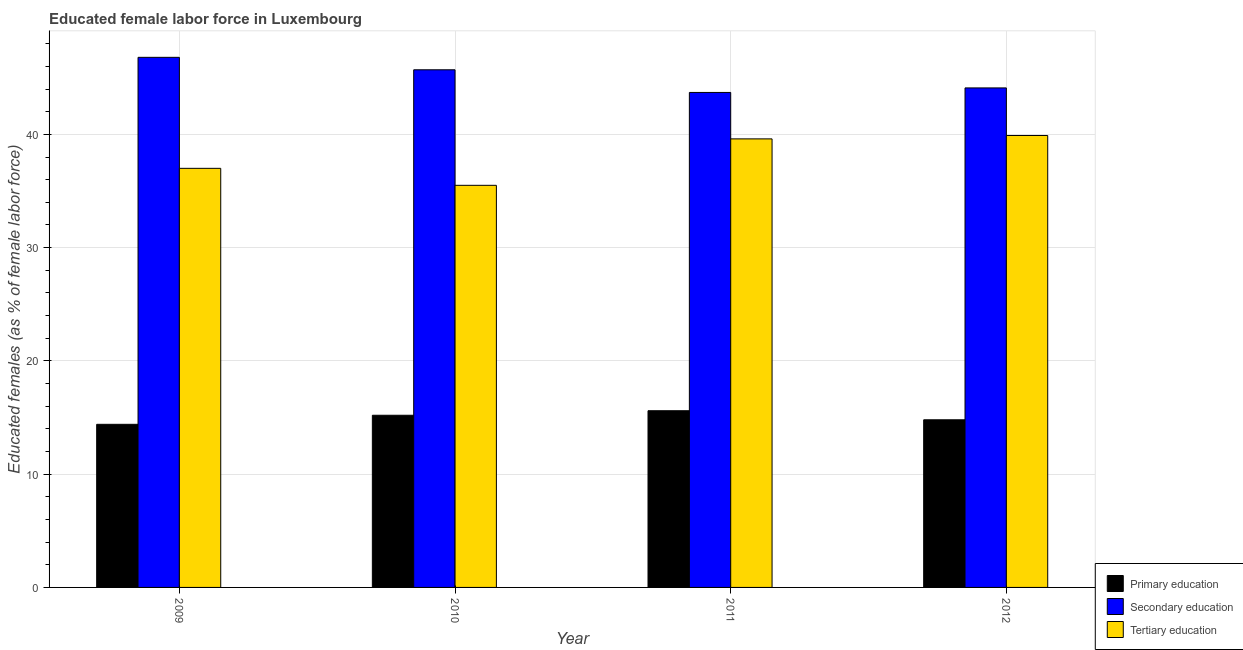How many different coloured bars are there?
Your answer should be compact. 3. Are the number of bars per tick equal to the number of legend labels?
Offer a terse response. Yes. Are the number of bars on each tick of the X-axis equal?
Make the answer very short. Yes. How many bars are there on the 4th tick from the right?
Make the answer very short. 3. What is the label of the 4th group of bars from the left?
Offer a very short reply. 2012. In how many cases, is the number of bars for a given year not equal to the number of legend labels?
Give a very brief answer. 0. What is the percentage of female labor force who received secondary education in 2010?
Your response must be concise. 45.7. Across all years, what is the maximum percentage of female labor force who received tertiary education?
Offer a very short reply. 39.9. Across all years, what is the minimum percentage of female labor force who received primary education?
Offer a terse response. 14.4. In which year was the percentage of female labor force who received primary education maximum?
Your answer should be compact. 2011. What is the total percentage of female labor force who received secondary education in the graph?
Make the answer very short. 180.3. What is the difference between the percentage of female labor force who received primary education in 2009 and that in 2010?
Offer a very short reply. -0.8. What is the difference between the percentage of female labor force who received primary education in 2011 and the percentage of female labor force who received secondary education in 2012?
Your answer should be compact. 0.8. What is the average percentage of female labor force who received tertiary education per year?
Provide a short and direct response. 38. In how many years, is the percentage of female labor force who received tertiary education greater than 34 %?
Your response must be concise. 4. What is the ratio of the percentage of female labor force who received primary education in 2009 to that in 2010?
Provide a succinct answer. 0.95. What is the difference between the highest and the second highest percentage of female labor force who received secondary education?
Make the answer very short. 1.1. What is the difference between the highest and the lowest percentage of female labor force who received primary education?
Provide a short and direct response. 1.2. Is the sum of the percentage of female labor force who received secondary education in 2009 and 2012 greater than the maximum percentage of female labor force who received primary education across all years?
Offer a terse response. Yes. What does the 2nd bar from the left in 2009 represents?
Keep it short and to the point. Secondary education. What does the 1st bar from the right in 2010 represents?
Your answer should be very brief. Tertiary education. What is the difference between two consecutive major ticks on the Y-axis?
Provide a succinct answer. 10. Does the graph contain any zero values?
Offer a terse response. No. How many legend labels are there?
Provide a short and direct response. 3. How are the legend labels stacked?
Provide a short and direct response. Vertical. What is the title of the graph?
Offer a terse response. Educated female labor force in Luxembourg. What is the label or title of the Y-axis?
Keep it short and to the point. Educated females (as % of female labor force). What is the Educated females (as % of female labor force) in Primary education in 2009?
Your answer should be compact. 14.4. What is the Educated females (as % of female labor force) in Secondary education in 2009?
Your answer should be very brief. 46.8. What is the Educated females (as % of female labor force) in Tertiary education in 2009?
Give a very brief answer. 37. What is the Educated females (as % of female labor force) in Primary education in 2010?
Your answer should be very brief. 15.2. What is the Educated females (as % of female labor force) in Secondary education in 2010?
Provide a short and direct response. 45.7. What is the Educated females (as % of female labor force) of Tertiary education in 2010?
Offer a terse response. 35.5. What is the Educated females (as % of female labor force) in Primary education in 2011?
Your response must be concise. 15.6. What is the Educated females (as % of female labor force) of Secondary education in 2011?
Offer a terse response. 43.7. What is the Educated females (as % of female labor force) in Tertiary education in 2011?
Your answer should be very brief. 39.6. What is the Educated females (as % of female labor force) in Primary education in 2012?
Provide a succinct answer. 14.8. What is the Educated females (as % of female labor force) of Secondary education in 2012?
Make the answer very short. 44.1. What is the Educated females (as % of female labor force) in Tertiary education in 2012?
Your response must be concise. 39.9. Across all years, what is the maximum Educated females (as % of female labor force) in Primary education?
Your answer should be very brief. 15.6. Across all years, what is the maximum Educated females (as % of female labor force) of Secondary education?
Give a very brief answer. 46.8. Across all years, what is the maximum Educated females (as % of female labor force) of Tertiary education?
Offer a terse response. 39.9. Across all years, what is the minimum Educated females (as % of female labor force) of Primary education?
Provide a succinct answer. 14.4. Across all years, what is the minimum Educated females (as % of female labor force) of Secondary education?
Provide a short and direct response. 43.7. Across all years, what is the minimum Educated females (as % of female labor force) in Tertiary education?
Your answer should be compact. 35.5. What is the total Educated females (as % of female labor force) of Primary education in the graph?
Offer a terse response. 60. What is the total Educated females (as % of female labor force) in Secondary education in the graph?
Your answer should be compact. 180.3. What is the total Educated females (as % of female labor force) in Tertiary education in the graph?
Your answer should be compact. 152. What is the difference between the Educated females (as % of female labor force) of Secondary education in 2009 and that in 2010?
Offer a terse response. 1.1. What is the difference between the Educated females (as % of female labor force) in Primary education in 2009 and that in 2011?
Ensure brevity in your answer.  -1.2. What is the difference between the Educated females (as % of female labor force) in Secondary education in 2009 and that in 2011?
Offer a terse response. 3.1. What is the difference between the Educated females (as % of female labor force) in Primary education in 2009 and that in 2012?
Your answer should be very brief. -0.4. What is the difference between the Educated females (as % of female labor force) in Secondary education in 2009 and that in 2012?
Your answer should be very brief. 2.7. What is the difference between the Educated females (as % of female labor force) of Primary education in 2010 and that in 2011?
Offer a terse response. -0.4. What is the difference between the Educated females (as % of female labor force) in Primary education in 2010 and that in 2012?
Keep it short and to the point. 0.4. What is the difference between the Educated females (as % of female labor force) in Tertiary education in 2011 and that in 2012?
Provide a short and direct response. -0.3. What is the difference between the Educated females (as % of female labor force) of Primary education in 2009 and the Educated females (as % of female labor force) of Secondary education in 2010?
Your answer should be compact. -31.3. What is the difference between the Educated females (as % of female labor force) in Primary education in 2009 and the Educated females (as % of female labor force) in Tertiary education in 2010?
Ensure brevity in your answer.  -21.1. What is the difference between the Educated females (as % of female labor force) of Primary education in 2009 and the Educated females (as % of female labor force) of Secondary education in 2011?
Your answer should be very brief. -29.3. What is the difference between the Educated females (as % of female labor force) of Primary education in 2009 and the Educated females (as % of female labor force) of Tertiary education in 2011?
Keep it short and to the point. -25.2. What is the difference between the Educated females (as % of female labor force) in Secondary education in 2009 and the Educated females (as % of female labor force) in Tertiary education in 2011?
Offer a very short reply. 7.2. What is the difference between the Educated females (as % of female labor force) in Primary education in 2009 and the Educated females (as % of female labor force) in Secondary education in 2012?
Provide a succinct answer. -29.7. What is the difference between the Educated females (as % of female labor force) in Primary education in 2009 and the Educated females (as % of female labor force) in Tertiary education in 2012?
Offer a very short reply. -25.5. What is the difference between the Educated females (as % of female labor force) in Primary education in 2010 and the Educated females (as % of female labor force) in Secondary education in 2011?
Make the answer very short. -28.5. What is the difference between the Educated females (as % of female labor force) of Primary education in 2010 and the Educated females (as % of female labor force) of Tertiary education in 2011?
Your answer should be very brief. -24.4. What is the difference between the Educated females (as % of female labor force) of Primary education in 2010 and the Educated females (as % of female labor force) of Secondary education in 2012?
Provide a short and direct response. -28.9. What is the difference between the Educated females (as % of female labor force) in Primary education in 2010 and the Educated females (as % of female labor force) in Tertiary education in 2012?
Keep it short and to the point. -24.7. What is the difference between the Educated females (as % of female labor force) in Secondary education in 2010 and the Educated females (as % of female labor force) in Tertiary education in 2012?
Your answer should be compact. 5.8. What is the difference between the Educated females (as % of female labor force) of Primary education in 2011 and the Educated females (as % of female labor force) of Secondary education in 2012?
Keep it short and to the point. -28.5. What is the difference between the Educated females (as % of female labor force) in Primary education in 2011 and the Educated females (as % of female labor force) in Tertiary education in 2012?
Provide a short and direct response. -24.3. What is the difference between the Educated females (as % of female labor force) in Secondary education in 2011 and the Educated females (as % of female labor force) in Tertiary education in 2012?
Give a very brief answer. 3.8. What is the average Educated females (as % of female labor force) of Primary education per year?
Keep it short and to the point. 15. What is the average Educated females (as % of female labor force) in Secondary education per year?
Provide a short and direct response. 45.08. In the year 2009, what is the difference between the Educated females (as % of female labor force) of Primary education and Educated females (as % of female labor force) of Secondary education?
Ensure brevity in your answer.  -32.4. In the year 2009, what is the difference between the Educated females (as % of female labor force) of Primary education and Educated females (as % of female labor force) of Tertiary education?
Your answer should be compact. -22.6. In the year 2009, what is the difference between the Educated females (as % of female labor force) of Secondary education and Educated females (as % of female labor force) of Tertiary education?
Make the answer very short. 9.8. In the year 2010, what is the difference between the Educated females (as % of female labor force) in Primary education and Educated females (as % of female labor force) in Secondary education?
Provide a succinct answer. -30.5. In the year 2010, what is the difference between the Educated females (as % of female labor force) of Primary education and Educated females (as % of female labor force) of Tertiary education?
Provide a succinct answer. -20.3. In the year 2011, what is the difference between the Educated females (as % of female labor force) in Primary education and Educated females (as % of female labor force) in Secondary education?
Your answer should be compact. -28.1. In the year 2011, what is the difference between the Educated females (as % of female labor force) of Primary education and Educated females (as % of female labor force) of Tertiary education?
Ensure brevity in your answer.  -24. In the year 2012, what is the difference between the Educated females (as % of female labor force) in Primary education and Educated females (as % of female labor force) in Secondary education?
Your answer should be very brief. -29.3. In the year 2012, what is the difference between the Educated females (as % of female labor force) of Primary education and Educated females (as % of female labor force) of Tertiary education?
Provide a short and direct response. -25.1. In the year 2012, what is the difference between the Educated females (as % of female labor force) of Secondary education and Educated females (as % of female labor force) of Tertiary education?
Your answer should be very brief. 4.2. What is the ratio of the Educated females (as % of female labor force) of Secondary education in 2009 to that in 2010?
Your answer should be very brief. 1.02. What is the ratio of the Educated females (as % of female labor force) in Tertiary education in 2009 to that in 2010?
Provide a succinct answer. 1.04. What is the ratio of the Educated females (as % of female labor force) in Secondary education in 2009 to that in 2011?
Offer a terse response. 1.07. What is the ratio of the Educated females (as % of female labor force) of Tertiary education in 2009 to that in 2011?
Give a very brief answer. 0.93. What is the ratio of the Educated females (as % of female labor force) in Secondary education in 2009 to that in 2012?
Keep it short and to the point. 1.06. What is the ratio of the Educated females (as % of female labor force) of Tertiary education in 2009 to that in 2012?
Offer a very short reply. 0.93. What is the ratio of the Educated females (as % of female labor force) in Primary education in 2010 to that in 2011?
Ensure brevity in your answer.  0.97. What is the ratio of the Educated females (as % of female labor force) in Secondary education in 2010 to that in 2011?
Keep it short and to the point. 1.05. What is the ratio of the Educated females (as % of female labor force) of Tertiary education in 2010 to that in 2011?
Offer a terse response. 0.9. What is the ratio of the Educated females (as % of female labor force) in Secondary education in 2010 to that in 2012?
Provide a short and direct response. 1.04. What is the ratio of the Educated females (as % of female labor force) of Tertiary education in 2010 to that in 2012?
Keep it short and to the point. 0.89. What is the ratio of the Educated females (as % of female labor force) in Primary education in 2011 to that in 2012?
Provide a succinct answer. 1.05. What is the ratio of the Educated females (as % of female labor force) in Secondary education in 2011 to that in 2012?
Your response must be concise. 0.99. What is the ratio of the Educated females (as % of female labor force) of Tertiary education in 2011 to that in 2012?
Provide a short and direct response. 0.99. What is the difference between the highest and the second highest Educated females (as % of female labor force) in Tertiary education?
Your response must be concise. 0.3. What is the difference between the highest and the lowest Educated females (as % of female labor force) of Secondary education?
Your response must be concise. 3.1. 